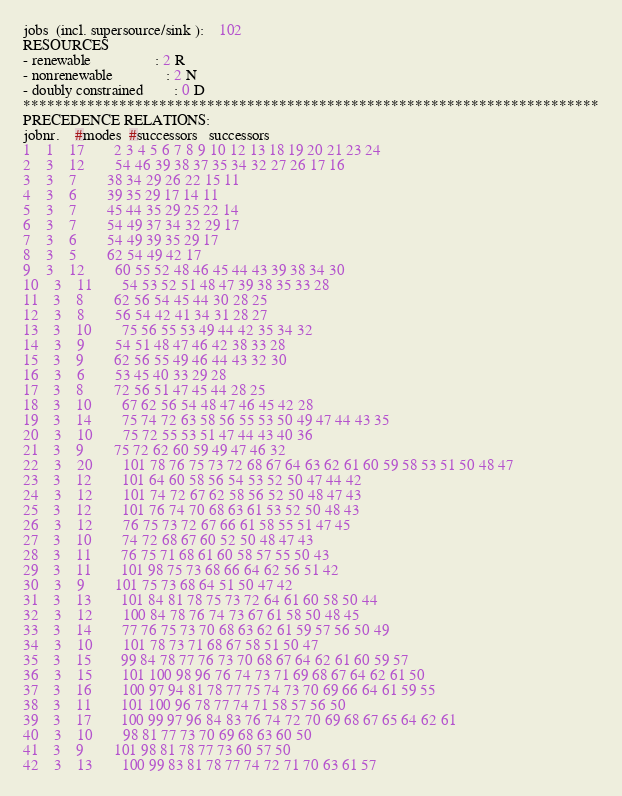Convert code to text. <code><loc_0><loc_0><loc_500><loc_500><_ObjectiveC_>jobs  (incl. supersource/sink ):	102
RESOURCES
- renewable                 : 2 R
- nonrenewable              : 2 N
- doubly constrained        : 0 D
************************************************************************
PRECEDENCE RELATIONS:
jobnr.    #modes  #successors   successors
1	1	17		2 3 4 5 6 7 8 9 10 12 13 18 19 20 21 23 24 
2	3	12		54 46 39 38 37 35 34 32 27 26 17 16 
3	3	7		38 34 29 26 22 15 11 
4	3	6		39 35 29 17 14 11 
5	3	7		45 44 35 29 25 22 14 
6	3	7		54 49 37 34 32 29 17 
7	3	6		54 49 39 35 29 17 
8	3	5		62 54 49 42 17 
9	3	12		60 55 52 48 46 45 44 43 39 38 34 30 
10	3	11		54 53 52 51 48 47 39 38 35 33 28 
11	3	8		62 56 54 45 44 30 28 25 
12	3	8		56 54 42 41 34 31 28 27 
13	3	10		75 56 55 53 49 44 42 35 34 32 
14	3	9		54 51 48 47 46 42 38 33 28 
15	3	9		62 56 55 49 46 44 43 32 30 
16	3	6		53 45 40 33 29 28 
17	3	8		72 56 51 47 45 44 28 25 
18	3	10		67 62 56 54 48 47 46 45 42 28 
19	3	14		75 74 72 63 58 56 55 53 50 49 47 44 43 35 
20	3	10		75 72 55 53 51 47 44 43 40 36 
21	3	9		75 72 62 60 59 49 47 46 32 
22	3	20		101 78 76 75 73 72 68 67 64 63 62 61 60 59 58 53 51 50 48 47 
23	3	12		101 64 60 58 56 54 53 52 50 47 44 42 
24	3	12		101 74 72 67 62 58 56 52 50 48 47 43 
25	3	12		101 76 74 70 68 63 61 53 52 50 48 43 
26	3	12		76 75 73 72 67 66 61 58 55 51 47 45 
27	3	10		74 72 68 67 60 52 50 48 47 43 
28	3	11		76 75 71 68 61 60 58 57 55 50 43 
29	3	11		101 98 75 73 68 66 64 62 56 51 42 
30	3	9		101 75 73 68 64 51 50 47 42 
31	3	13		101 84 81 78 75 73 72 64 61 60 58 50 44 
32	3	12		100 84 78 76 74 73 67 61 58 50 48 45 
33	3	14		77 76 75 73 70 68 63 62 61 59 57 56 50 49 
34	3	10		101 78 73 71 68 67 58 51 50 47 
35	3	15		99 84 78 77 76 73 70 68 67 64 62 61 60 59 57 
36	3	15		101 100 98 96 76 74 73 71 69 68 67 64 62 61 50 
37	3	16		100 97 94 81 78 77 75 74 73 70 69 66 64 61 59 55 
38	3	11		101 100 96 78 77 74 71 58 57 56 50 
39	3	17		100 99 97 96 84 83 76 74 72 70 69 68 67 65 64 62 61 
40	3	10		98 81 77 73 70 69 68 63 60 50 
41	3	9		101 98 81 78 77 73 60 57 50 
42	3	13		100 99 83 81 78 77 74 72 71 70 63 61 57 </code> 